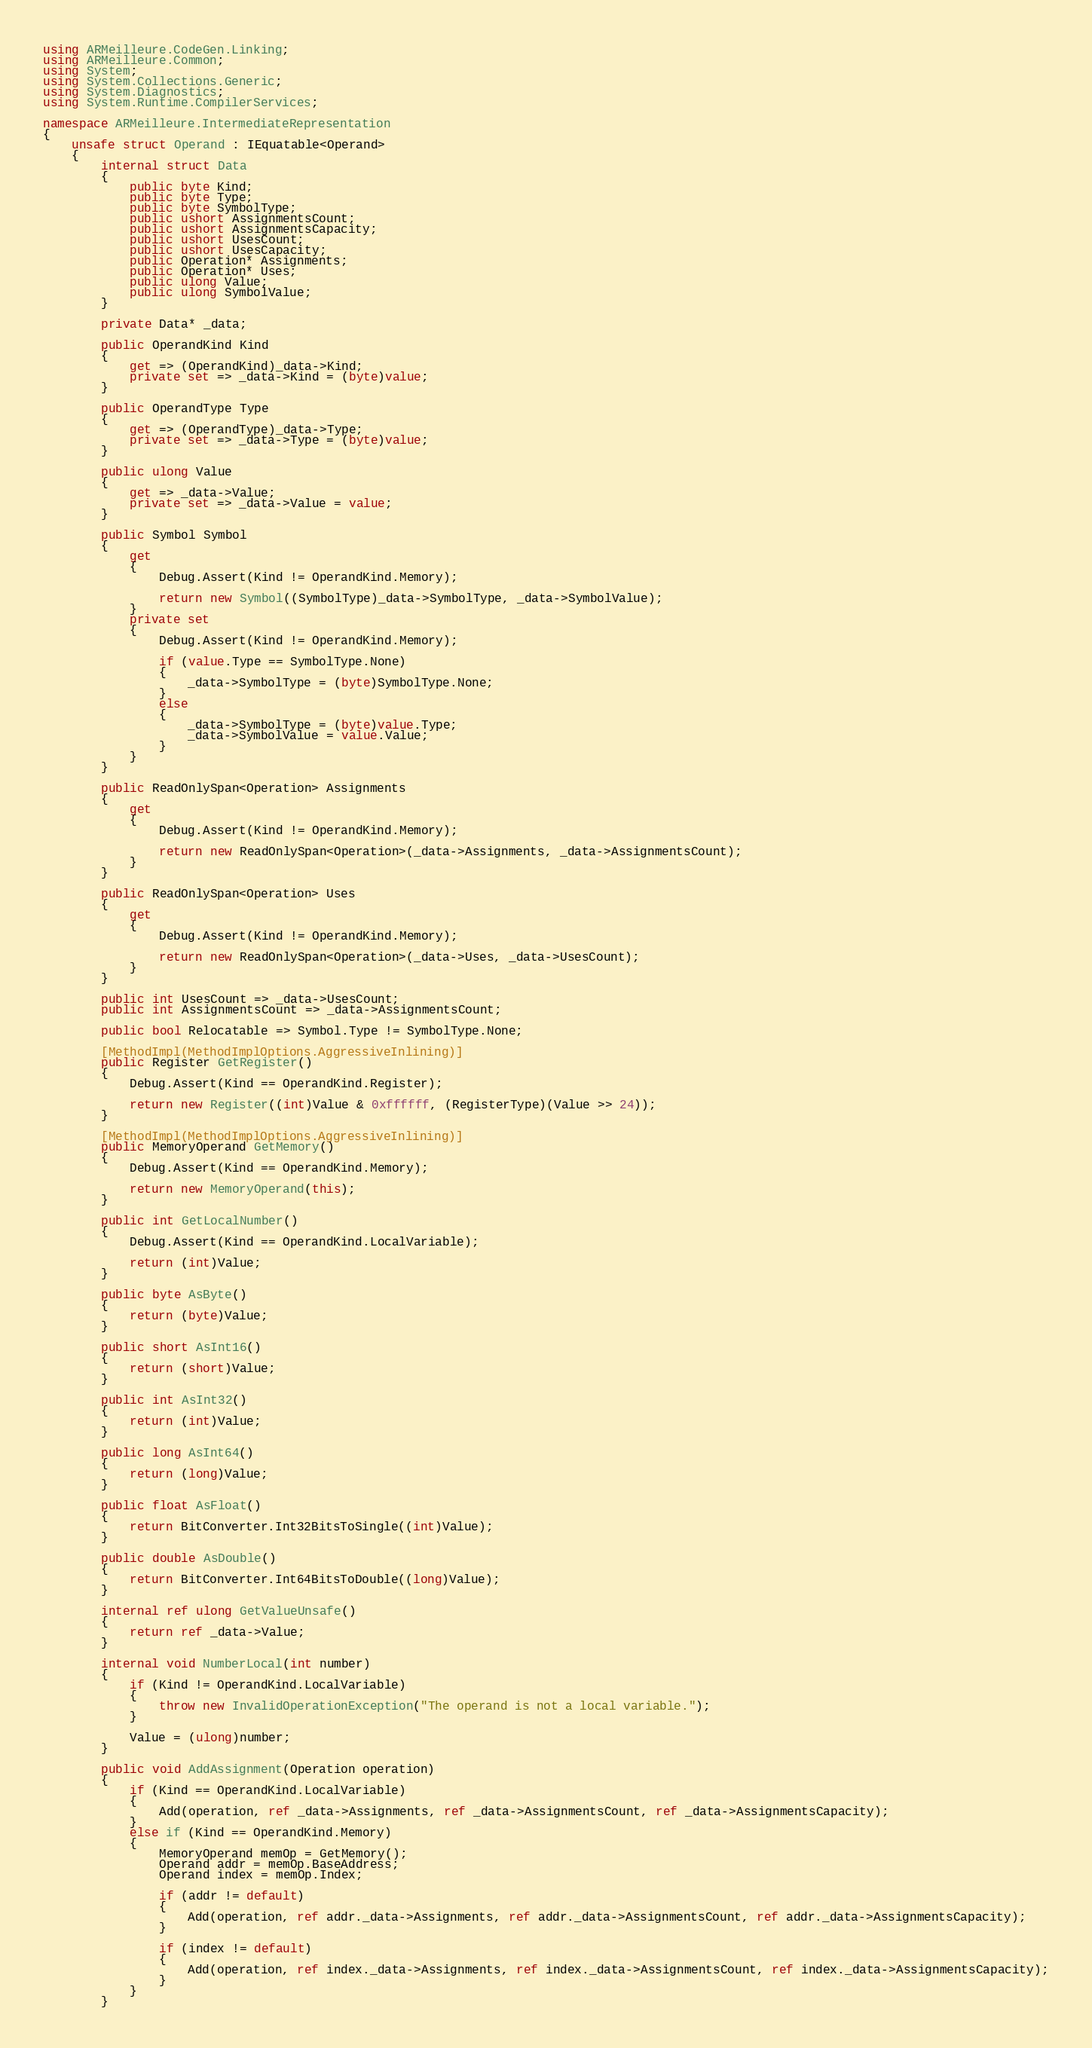<code> <loc_0><loc_0><loc_500><loc_500><_C#_>using ARMeilleure.CodeGen.Linking;
using ARMeilleure.Common;
using System;
using System.Collections.Generic;
using System.Diagnostics;
using System.Runtime.CompilerServices;

namespace ARMeilleure.IntermediateRepresentation
{
    unsafe struct Operand : IEquatable<Operand>
    {
        internal struct Data
        {
            public byte Kind;
            public byte Type;
            public byte SymbolType;
            public ushort AssignmentsCount;
            public ushort AssignmentsCapacity;
            public ushort UsesCount;
            public ushort UsesCapacity;
            public Operation* Assignments;
            public Operation* Uses;
            public ulong Value;
            public ulong SymbolValue;
        }

        private Data* _data;

        public OperandKind Kind
        {
            get => (OperandKind)_data->Kind;
            private set => _data->Kind = (byte)value;
        }

        public OperandType Type
        {
            get => (OperandType)_data->Type;
            private set => _data->Type = (byte)value;
        }

        public ulong Value
        {
            get => _data->Value;
            private set => _data->Value = value;
        }

        public Symbol Symbol
        {
            get
            {
                Debug.Assert(Kind != OperandKind.Memory);

                return new Symbol((SymbolType)_data->SymbolType, _data->SymbolValue);
            }
            private set
            {
                Debug.Assert(Kind != OperandKind.Memory);

                if (value.Type == SymbolType.None)
                {
                    _data->SymbolType = (byte)SymbolType.None;
                }
                else
                {
                    _data->SymbolType = (byte)value.Type;
                    _data->SymbolValue = value.Value;
                }
            }
        }

        public ReadOnlySpan<Operation> Assignments
        {
            get
            {
                Debug.Assert(Kind != OperandKind.Memory);

                return new ReadOnlySpan<Operation>(_data->Assignments, _data->AssignmentsCount);
            }
        }

        public ReadOnlySpan<Operation> Uses
        {
            get
            {
                Debug.Assert(Kind != OperandKind.Memory);

                return new ReadOnlySpan<Operation>(_data->Uses, _data->UsesCount);
            }
        }

        public int UsesCount => _data->UsesCount;
        public int AssignmentsCount => _data->AssignmentsCount;

        public bool Relocatable => Symbol.Type != SymbolType.None;

        [MethodImpl(MethodImplOptions.AggressiveInlining)]
        public Register GetRegister()
        {
            Debug.Assert(Kind == OperandKind.Register);

            return new Register((int)Value & 0xffffff, (RegisterType)(Value >> 24));
        }

        [MethodImpl(MethodImplOptions.AggressiveInlining)]
        public MemoryOperand GetMemory()
        {
            Debug.Assert(Kind == OperandKind.Memory);

            return new MemoryOperand(this);
        }

        public int GetLocalNumber()
        {
            Debug.Assert(Kind == OperandKind.LocalVariable);

            return (int)Value;
        }

        public byte AsByte()
        {
            return (byte)Value;
        }

        public short AsInt16()
        {
            return (short)Value;
        }

        public int AsInt32()
        {
            return (int)Value;
        }

        public long AsInt64()
        {
            return (long)Value;
        }

        public float AsFloat()
        {
            return BitConverter.Int32BitsToSingle((int)Value);
        }

        public double AsDouble()
        {
            return BitConverter.Int64BitsToDouble((long)Value);
        }

        internal ref ulong GetValueUnsafe()
        {
            return ref _data->Value;
        }

        internal void NumberLocal(int number)
        {
            if (Kind != OperandKind.LocalVariable)
            {
                throw new InvalidOperationException("The operand is not a local variable.");
            }

            Value = (ulong)number;
        }

        public void AddAssignment(Operation operation)
        {
            if (Kind == OperandKind.LocalVariable)
            {
                Add(operation, ref _data->Assignments, ref _data->AssignmentsCount, ref _data->AssignmentsCapacity);
            }
            else if (Kind == OperandKind.Memory)
            {
                MemoryOperand memOp = GetMemory();
                Operand addr = memOp.BaseAddress;
                Operand index = memOp.Index;

                if (addr != default)
                {
                    Add(operation, ref addr._data->Assignments, ref addr._data->AssignmentsCount, ref addr._data->AssignmentsCapacity);
                }
                
                if (index != default)
                {
                    Add(operation, ref index._data->Assignments, ref index._data->AssignmentsCount, ref index._data->AssignmentsCapacity);
                }
            }
        }
</code> 